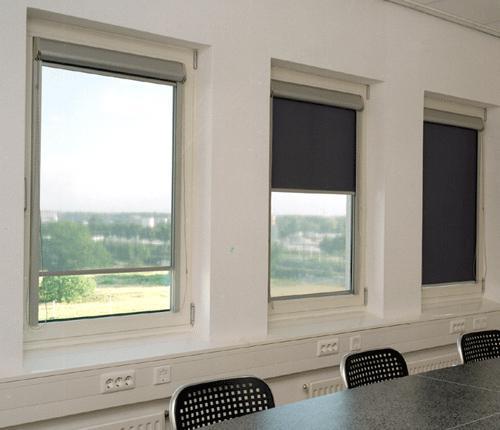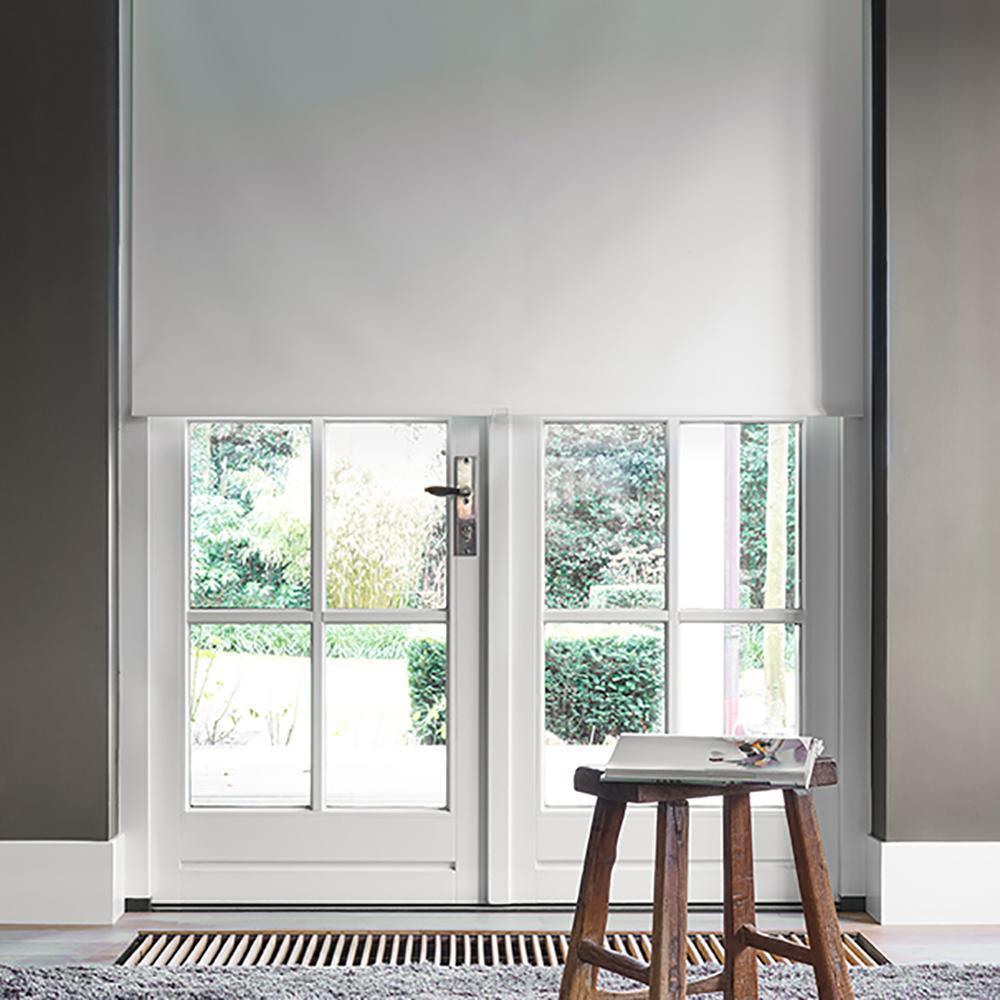The first image is the image on the left, the second image is the image on the right. Examine the images to the left and right. Is the description "In at least one image there are three blinds behind at least two chairs." accurate? Answer yes or no. Yes. 